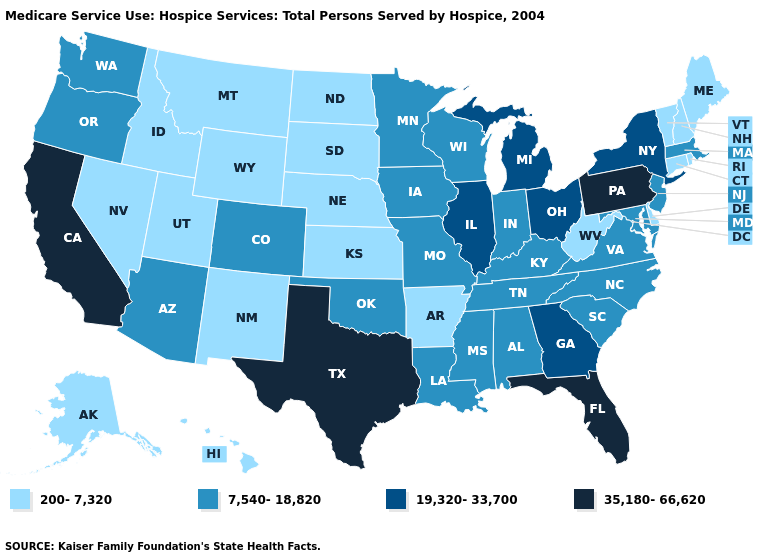Name the states that have a value in the range 200-7,320?
Write a very short answer. Alaska, Arkansas, Connecticut, Delaware, Hawaii, Idaho, Kansas, Maine, Montana, Nebraska, Nevada, New Hampshire, New Mexico, North Dakota, Rhode Island, South Dakota, Utah, Vermont, West Virginia, Wyoming. Does Massachusetts have a higher value than North Dakota?
Quick response, please. Yes. Which states have the lowest value in the West?
Quick response, please. Alaska, Hawaii, Idaho, Montana, Nevada, New Mexico, Utah, Wyoming. Name the states that have a value in the range 35,180-66,620?
Answer briefly. California, Florida, Pennsylvania, Texas. Does Maine have the lowest value in the Northeast?
Quick response, please. Yes. Does Alabama have the same value as Montana?
Answer briefly. No. Name the states that have a value in the range 35,180-66,620?
Give a very brief answer. California, Florida, Pennsylvania, Texas. What is the value of North Dakota?
Give a very brief answer. 200-7,320. What is the value of North Carolina?
Concise answer only. 7,540-18,820. What is the value of North Carolina?
Keep it brief. 7,540-18,820. Name the states that have a value in the range 19,320-33,700?
Short answer required. Georgia, Illinois, Michigan, New York, Ohio. What is the value of New Mexico?
Answer briefly. 200-7,320. What is the value of Georgia?
Answer briefly. 19,320-33,700. What is the value of North Dakota?
Write a very short answer. 200-7,320. What is the value of Maine?
Concise answer only. 200-7,320. 